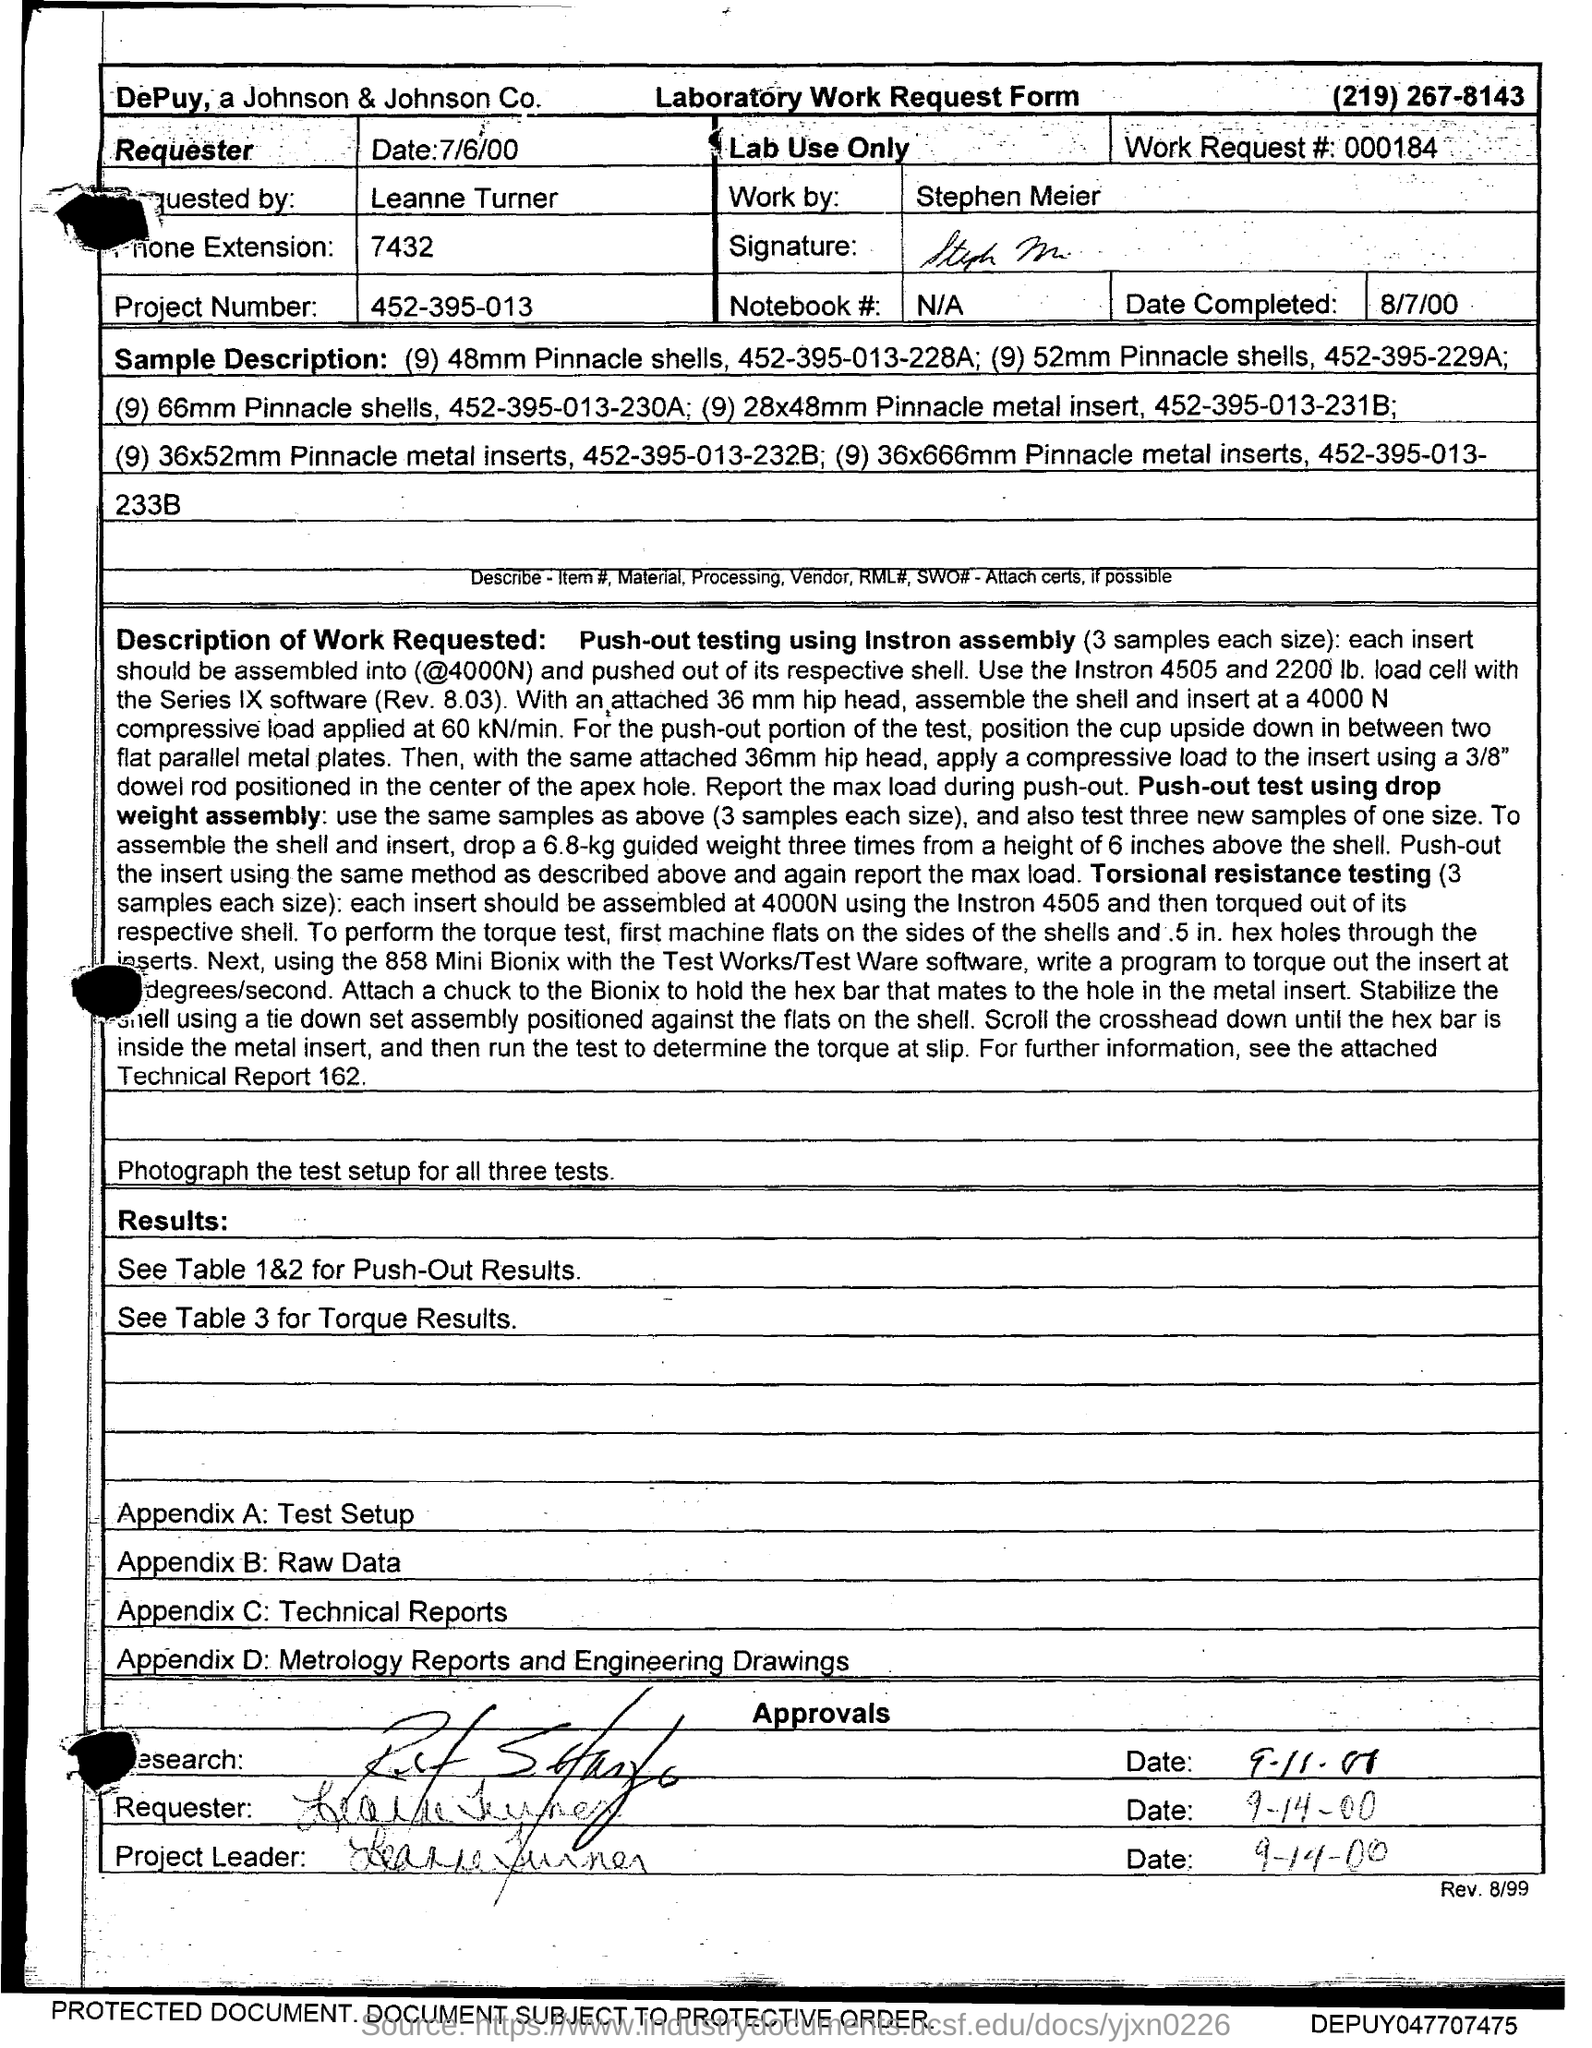Draw attention to some important aspects in this diagram. The document in question is the Laboratory Work Request Form of Depuy, a subsidiary of Johnson & Johnson. Stephen Meier has done the laboratory work. The project number provided in the form is 452-395-013. Please provide the work request number in the form, which is 000184... The Notebook number, when given in the form, is marked as "N/A". 